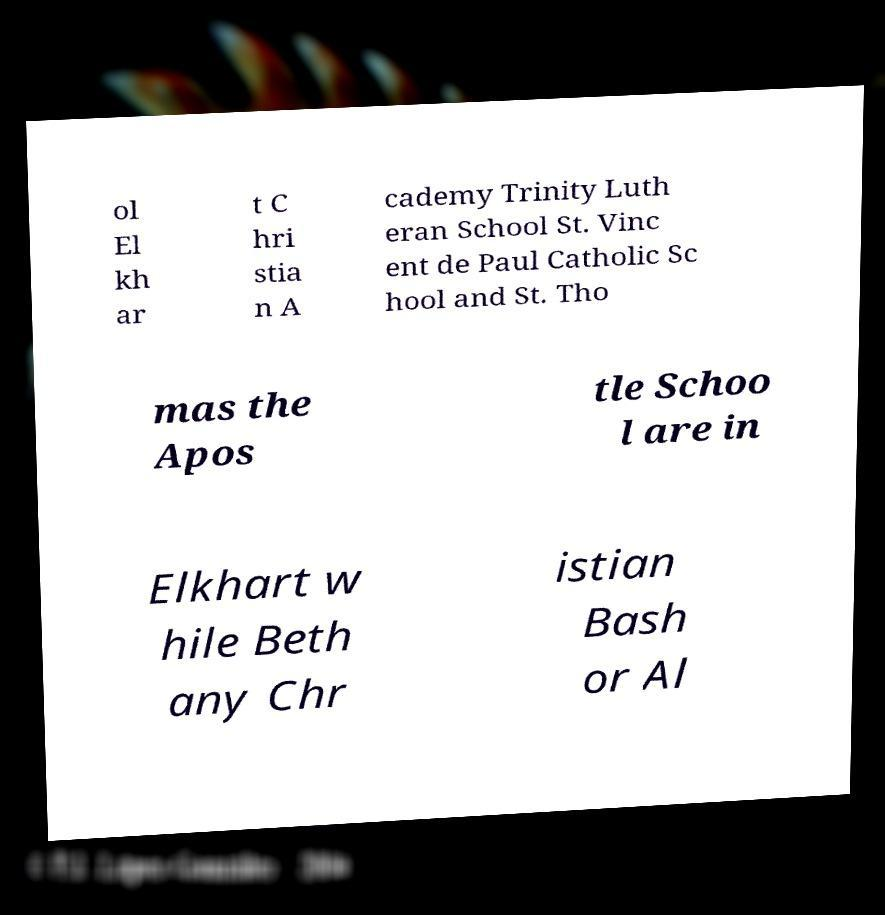Can you read and provide the text displayed in the image?This photo seems to have some interesting text. Can you extract and type it out for me? ol El kh ar t C hri stia n A cademy Trinity Luth eran School St. Vinc ent de Paul Catholic Sc hool and St. Tho mas the Apos tle Schoo l are in Elkhart w hile Beth any Chr istian Bash or Al 